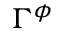<formula> <loc_0><loc_0><loc_500><loc_500>\Gamma ^ { \phi }</formula> 